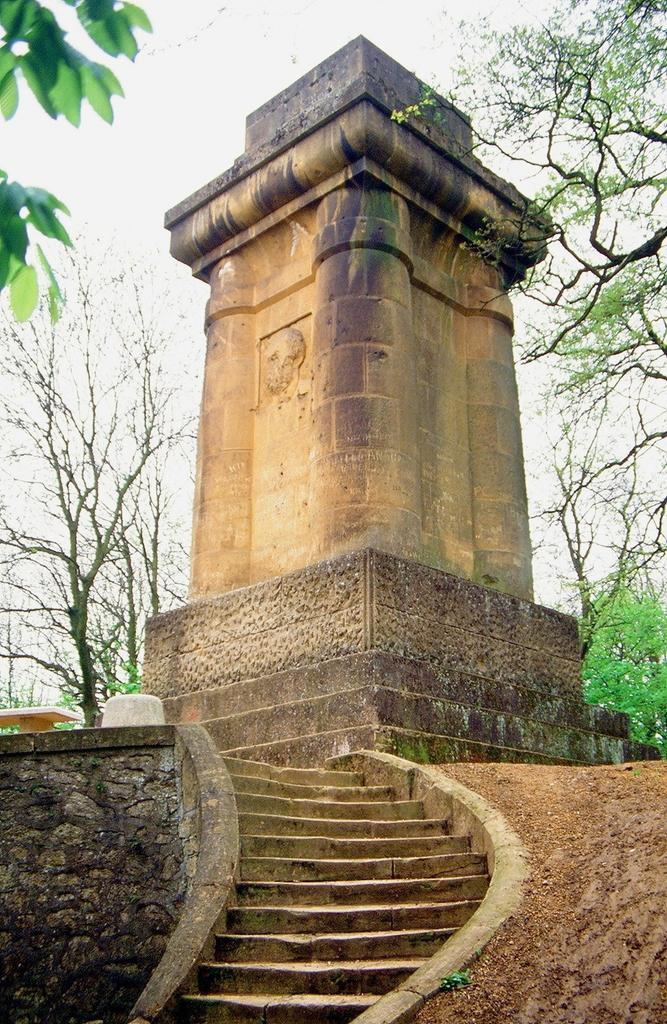Could you give a brief overview of what you see in this image? This picture is clicked outside. In the foreground we can see the stairway. In the center there is an object which seems to be the monument. In the background we can see the wall, trees and some other objects. 